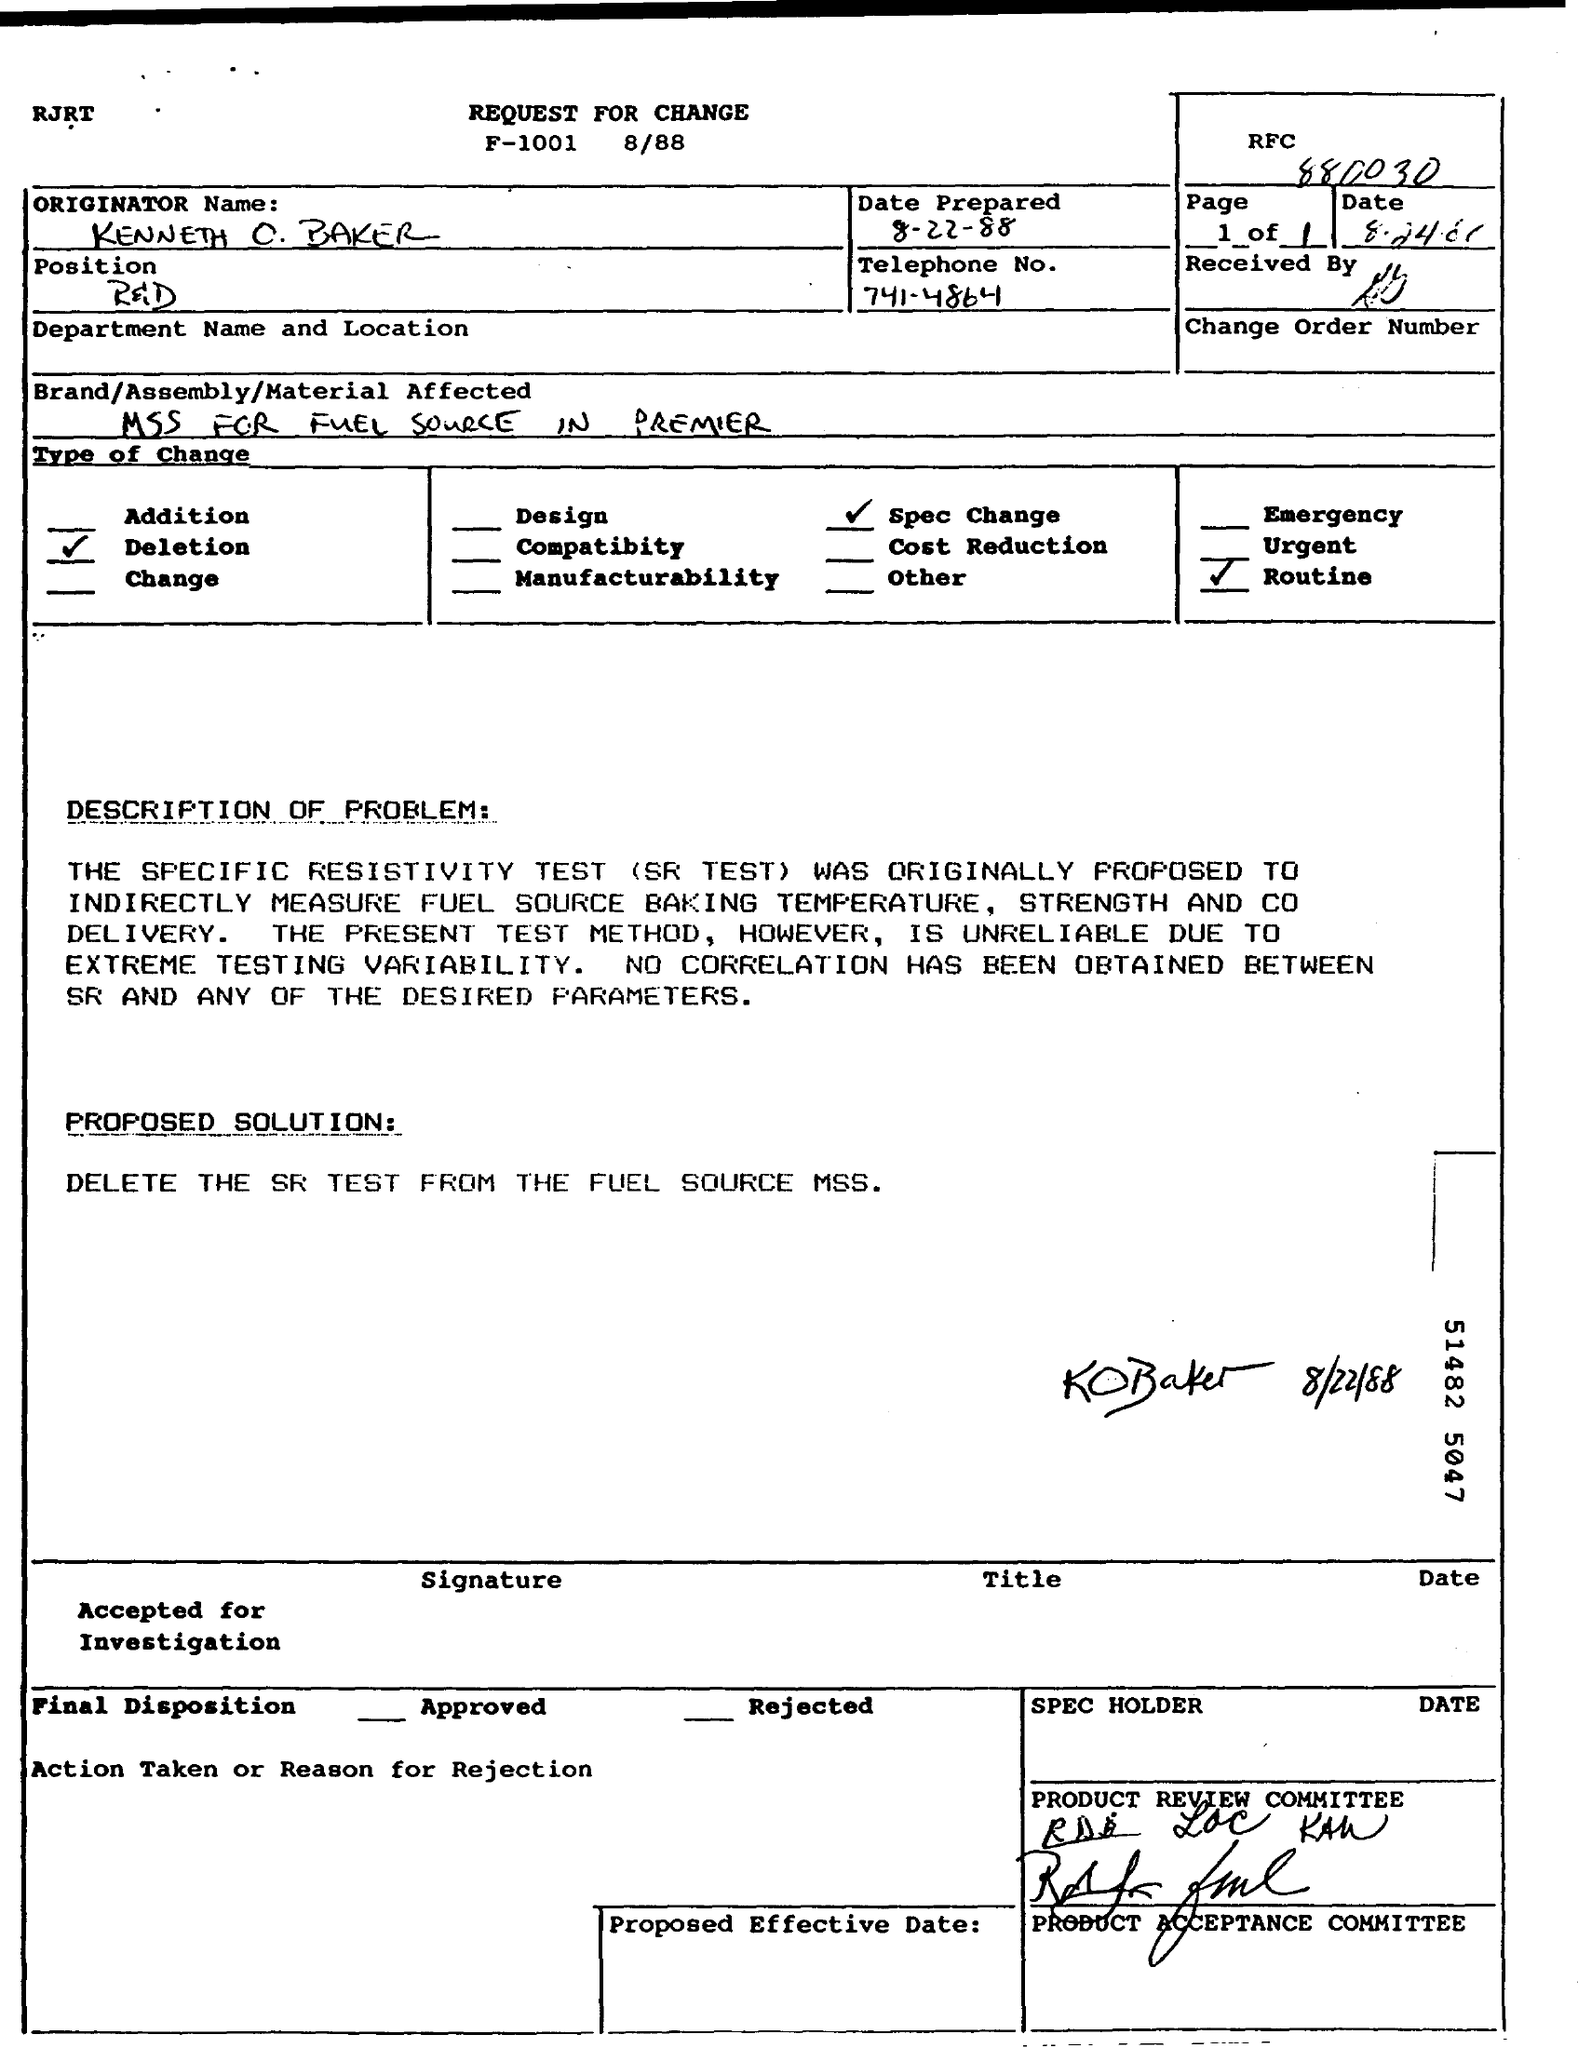Who originally prepared this document? The document appears to be prepared by an individual whose name is partially visible as 'Kenneth C.' followed by a surname that is not fully clear. Their position and telephone number are also given. Has the proposed change been approved? Based on the information in the document, it seems that the proposed change has been approved, as evidenced by the signatures and initials in the relevant sections. 